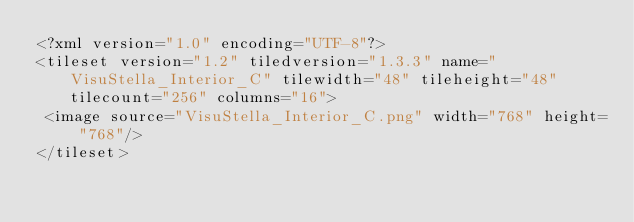Convert code to text. <code><loc_0><loc_0><loc_500><loc_500><_TypeScript_><?xml version="1.0" encoding="UTF-8"?>
<tileset version="1.2" tiledversion="1.3.3" name="VisuStella_Interior_C" tilewidth="48" tileheight="48" tilecount="256" columns="16">
 <image source="VisuStella_Interior_C.png" width="768" height="768"/>
</tileset>
</code> 